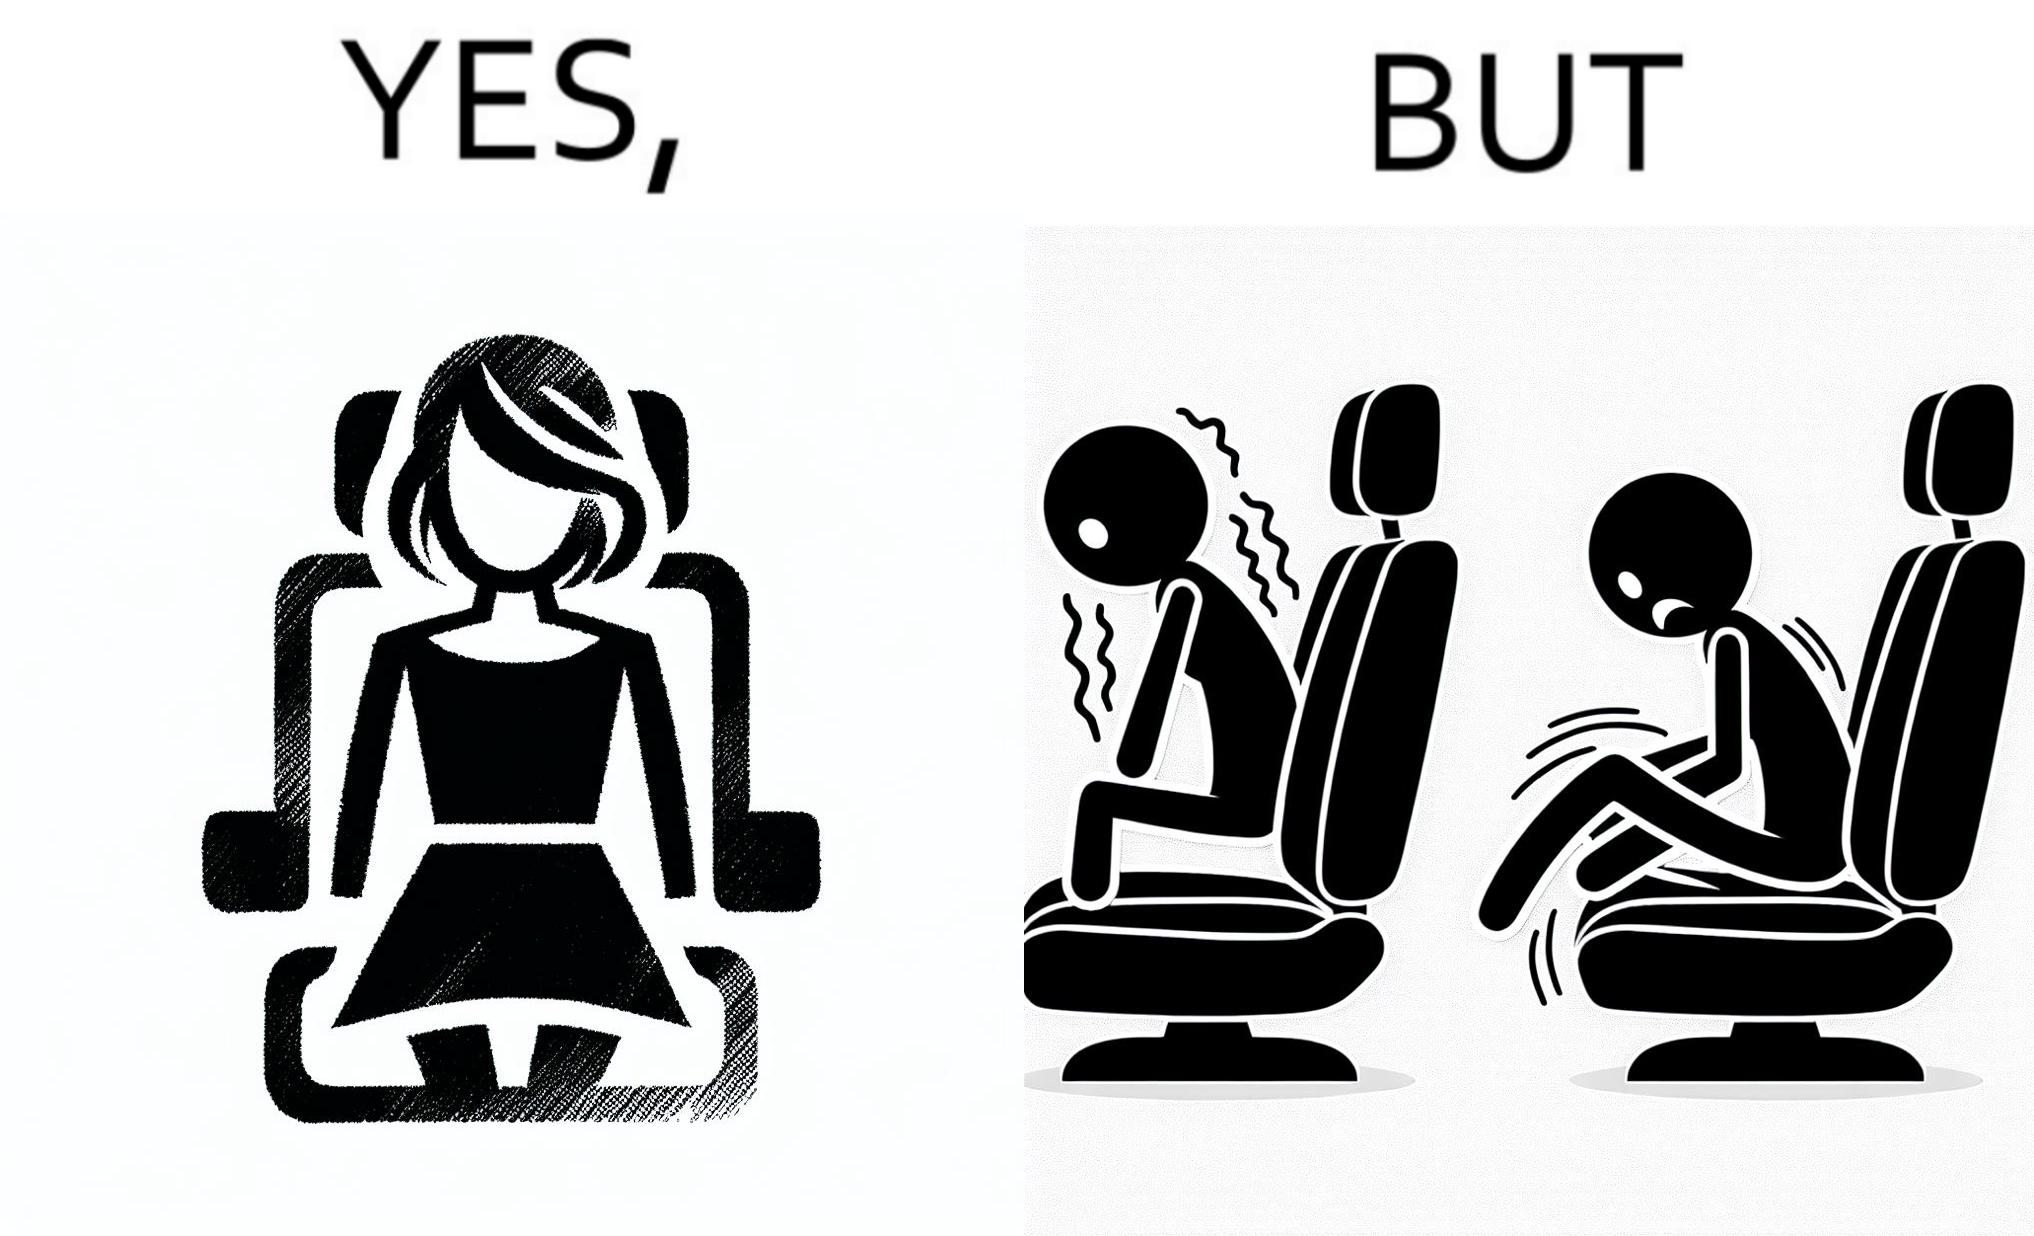Would you classify this image as satirical? Yes, this image is satirical. 